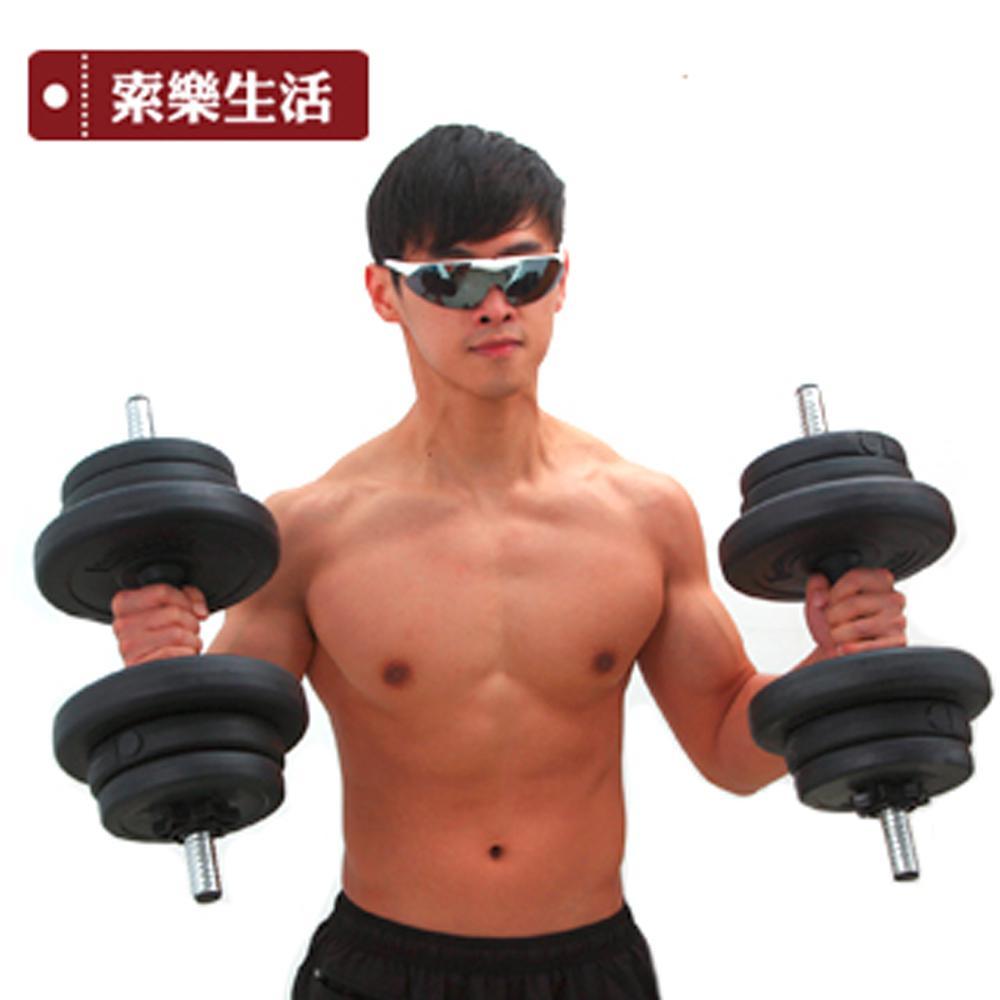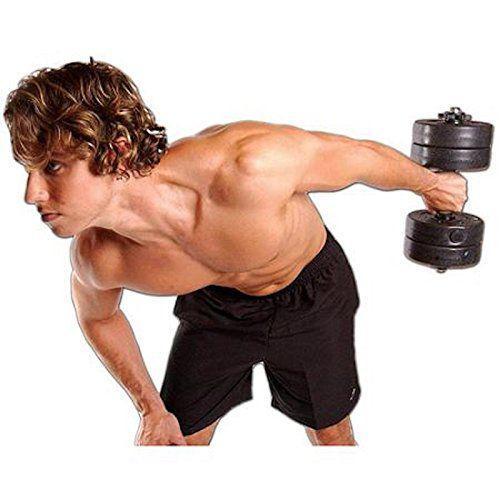The first image is the image on the left, the second image is the image on the right. Evaluate the accuracy of this statement regarding the images: "There are exactly two men in the image on the right.". Is it true? Answer yes or no. No. 